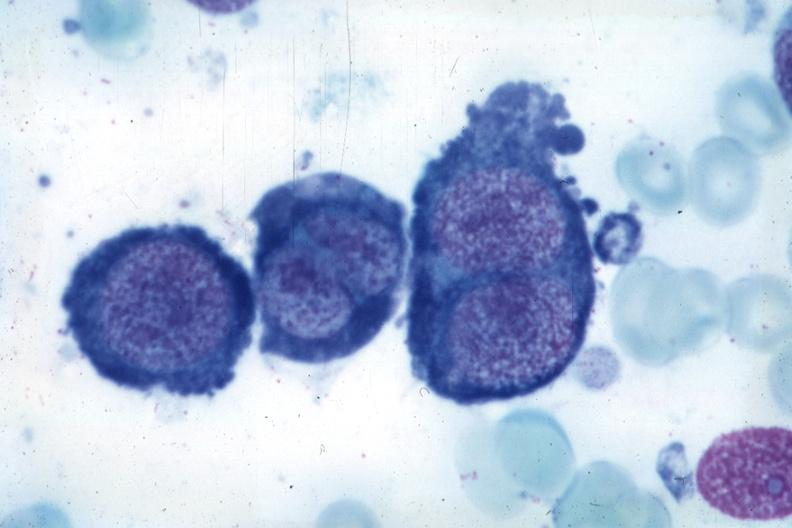s bone marrow present?
Answer the question using a single word or phrase. Yes 